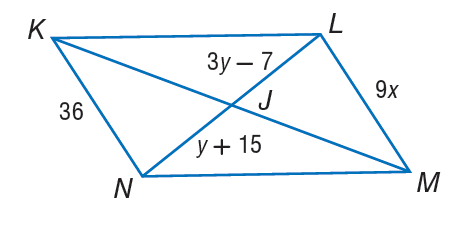Question: If K L M N is a parallelogram, find y.
Choices:
A. 11
B. 17
C. 26
D. 28
Answer with the letter. Answer: A Question: If K L M N is a parallelogram, fnd x.
Choices:
A. 4
B. 5
C. 12
D. 26
Answer with the letter. Answer: A 